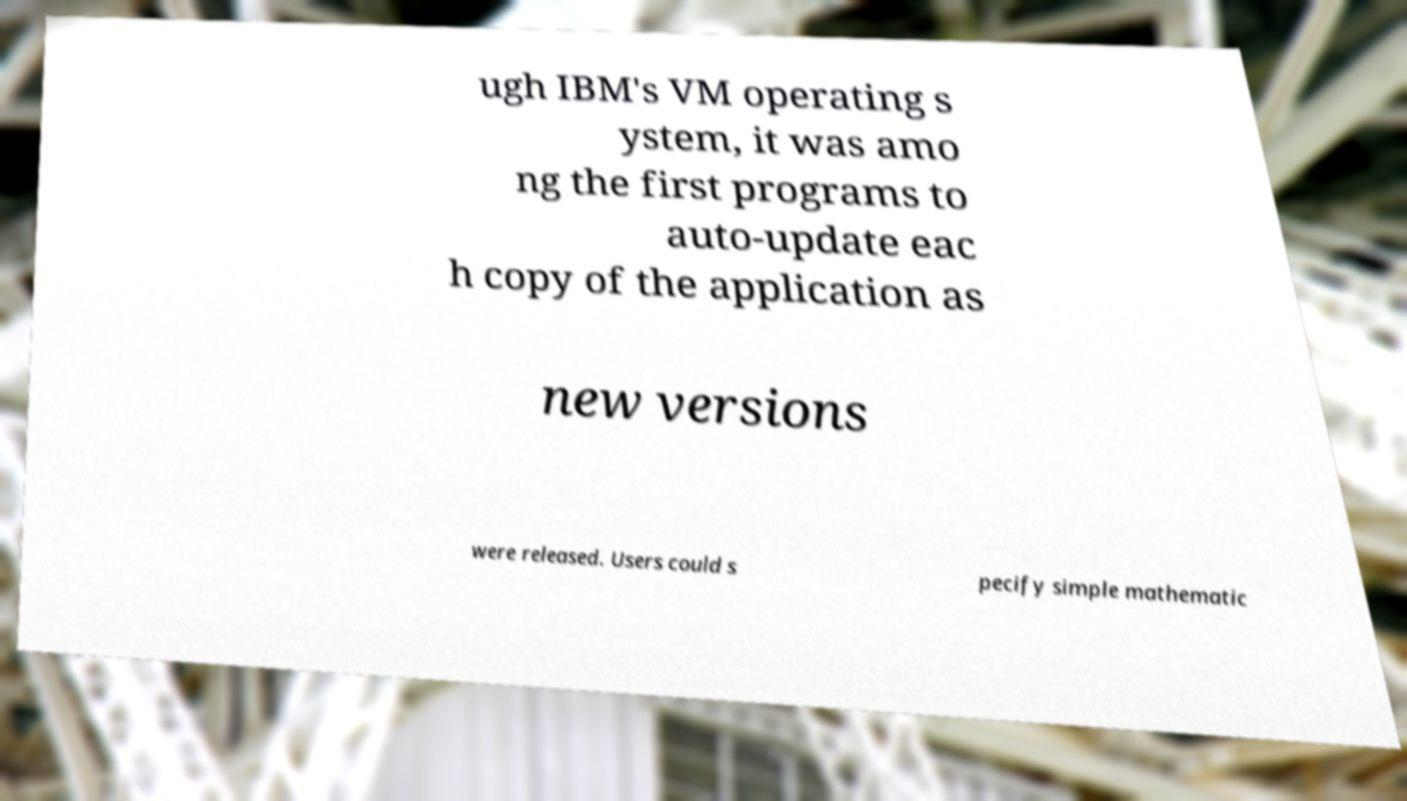Could you extract and type out the text from this image? ugh IBM's VM operating s ystem, it was amo ng the first programs to auto-update eac h copy of the application as new versions were released. Users could s pecify simple mathematic 